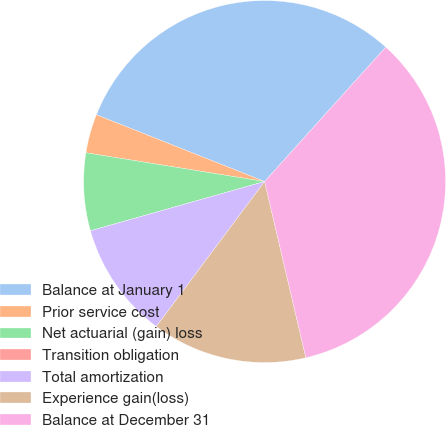<chart> <loc_0><loc_0><loc_500><loc_500><pie_chart><fcel>Balance at January 1<fcel>Prior service cost<fcel>Net actuarial (gain) loss<fcel>Transition obligation<fcel>Total amortization<fcel>Experience gain(loss)<fcel>Balance at December 31<nl><fcel>30.66%<fcel>3.47%<fcel>6.93%<fcel>0.0%<fcel>10.4%<fcel>13.87%<fcel>34.66%<nl></chart> 